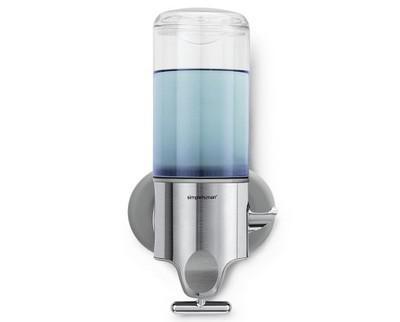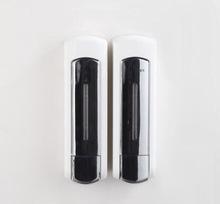The first image is the image on the left, the second image is the image on the right. Given the left and right images, does the statement "An image shows side-by-side dispensers with black dispenser 'buttons'." hold true? Answer yes or no. Yes. The first image is the image on the left, the second image is the image on the right. Given the left and right images, does the statement "Exactly three wall mounted bathroom dispensers are shown, with two matching dispensers in one image and different third dispenser in the other image." hold true? Answer yes or no. Yes. 